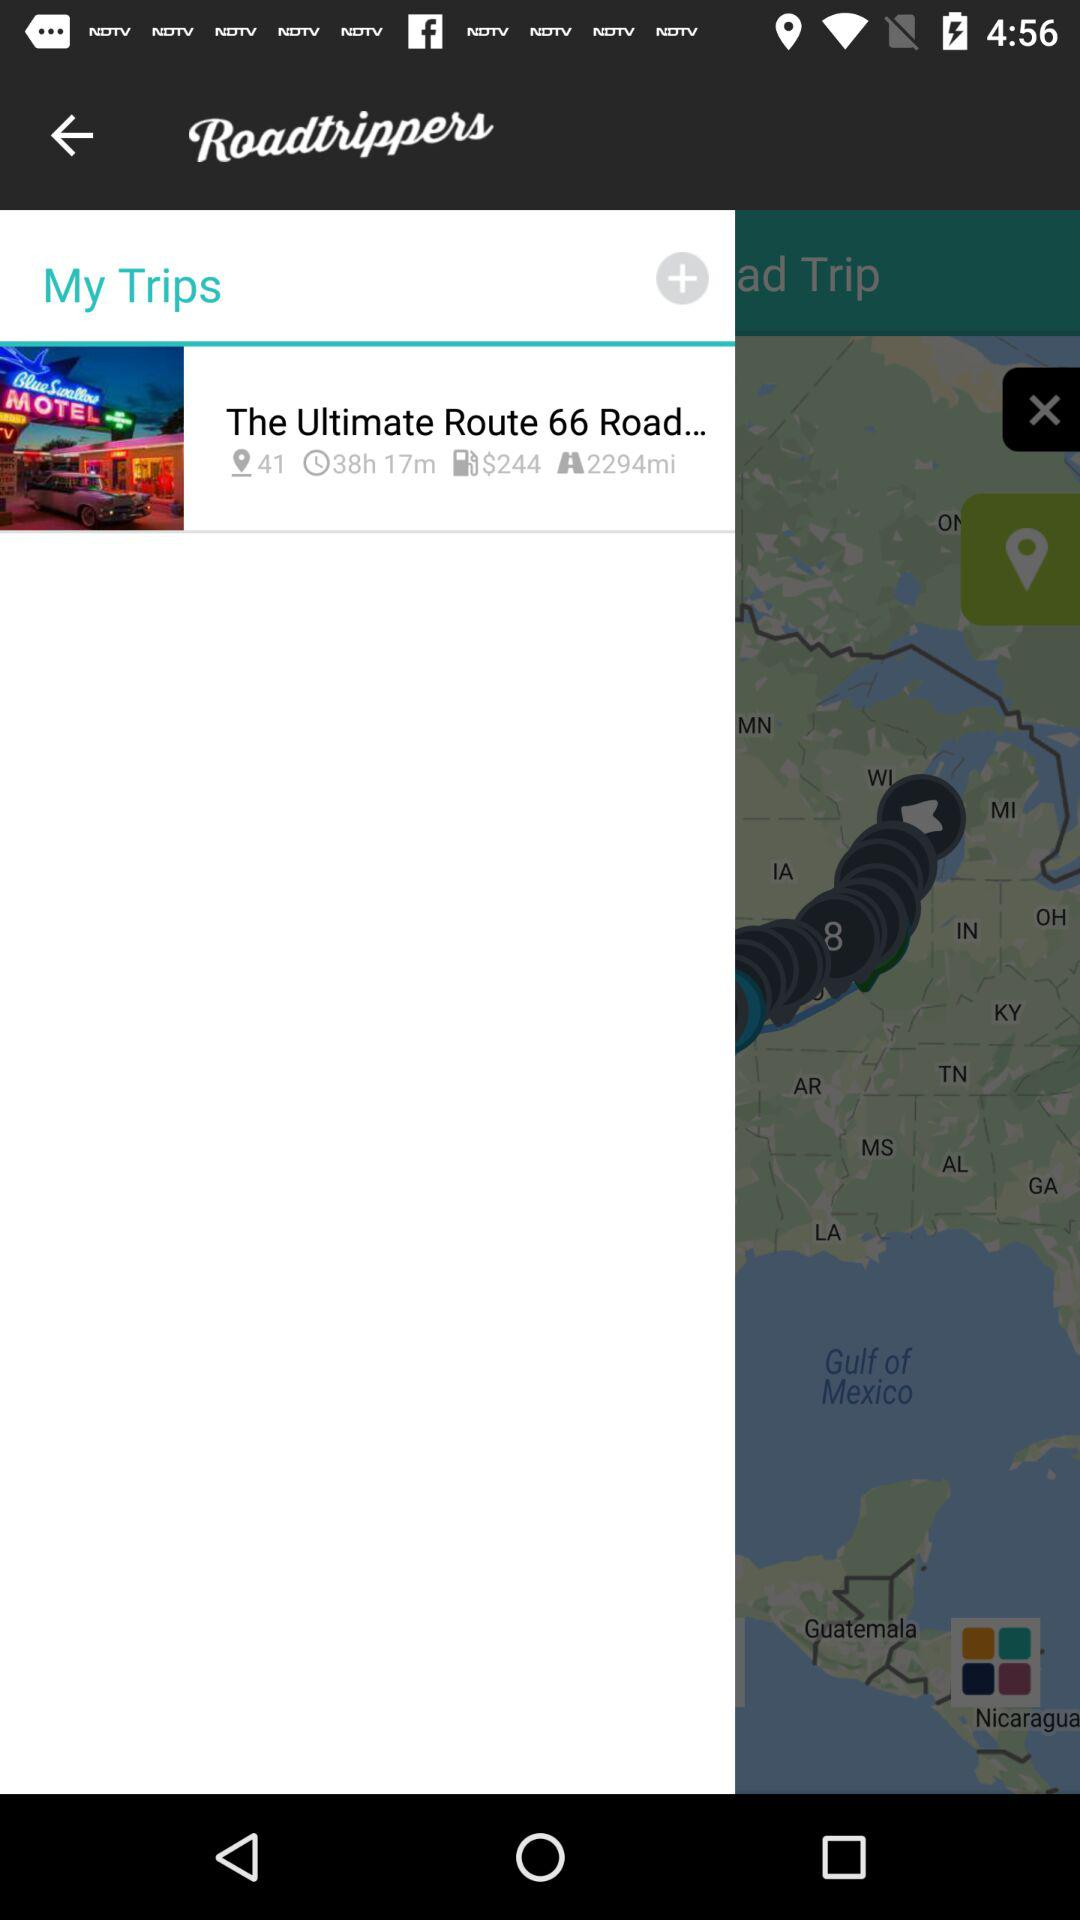What was the time taken to travel "The Ultimate Route 66 Road..."? The time taken was 38 hours and 17 minutes. 